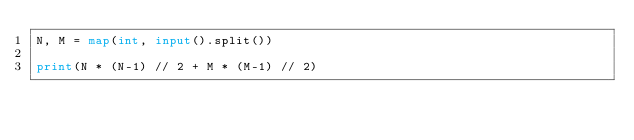Convert code to text. <code><loc_0><loc_0><loc_500><loc_500><_Python_>N, M = map(int, input().split())

print(N * (N-1) // 2 + M * (M-1) // 2)
</code> 